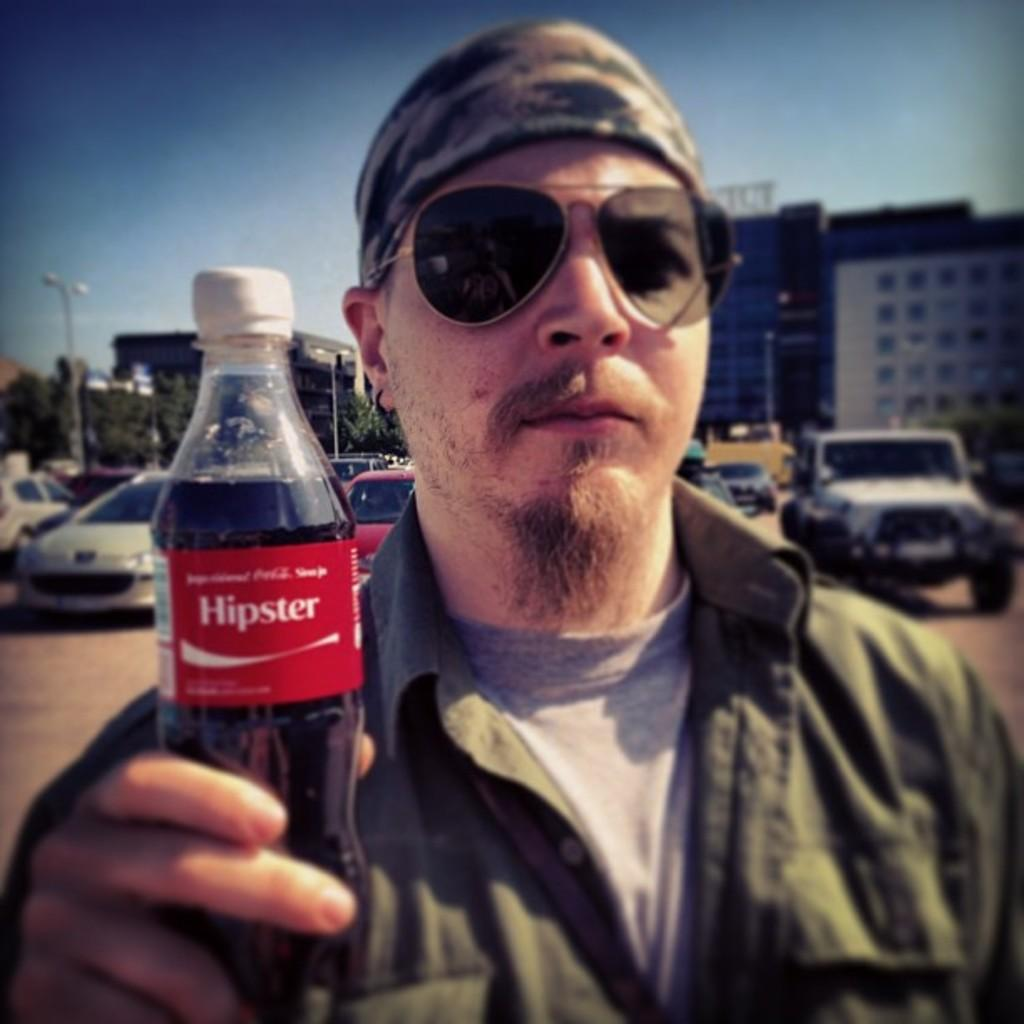What is the man in the image doing? The man is standing in the image and holding a bottle in his hands. What can be seen in the background of the image? There are cars and a building visible in the background of the image. What is visible in the sky in the image? The sky is visible in the image. What type of pin can be seen holding the circle together in the image? There is no circle or pin present in the image. 